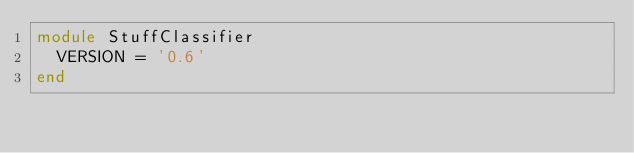<code> <loc_0><loc_0><loc_500><loc_500><_Ruby_>module StuffClassifier
  VERSION = '0.6'
end
</code> 